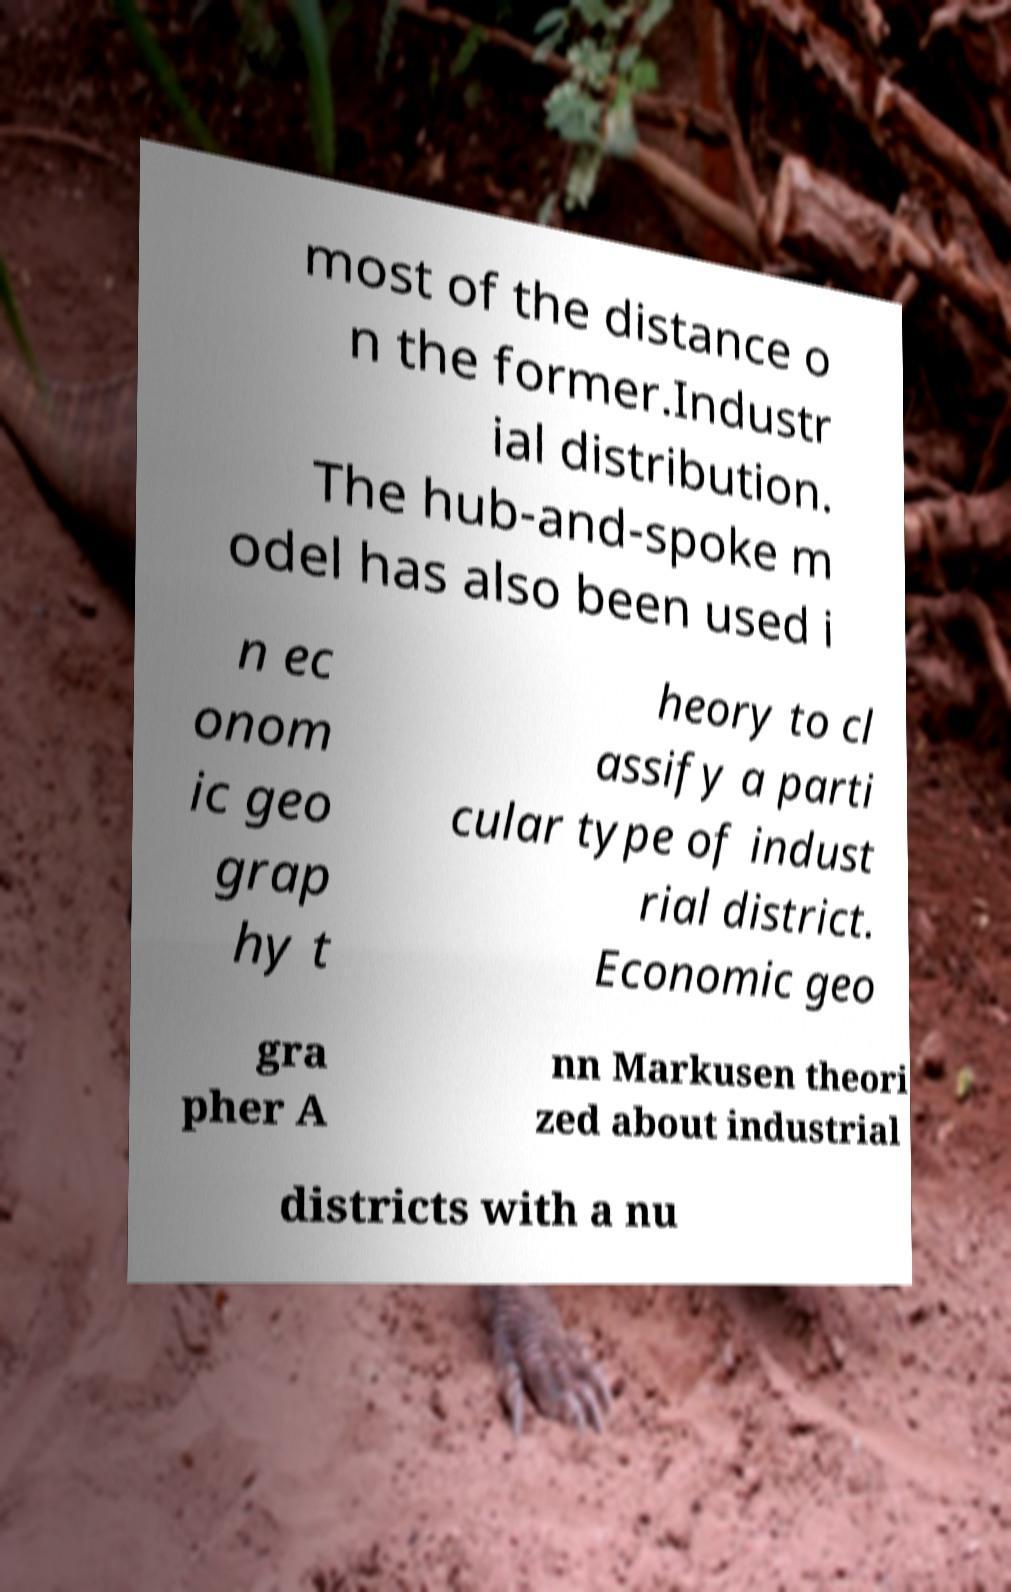There's text embedded in this image that I need extracted. Can you transcribe it verbatim? most of the distance o n the former.Industr ial distribution. The hub-and-spoke m odel has also been used i n ec onom ic geo grap hy t heory to cl assify a parti cular type of indust rial district. Economic geo gra pher A nn Markusen theori zed about industrial districts with a nu 